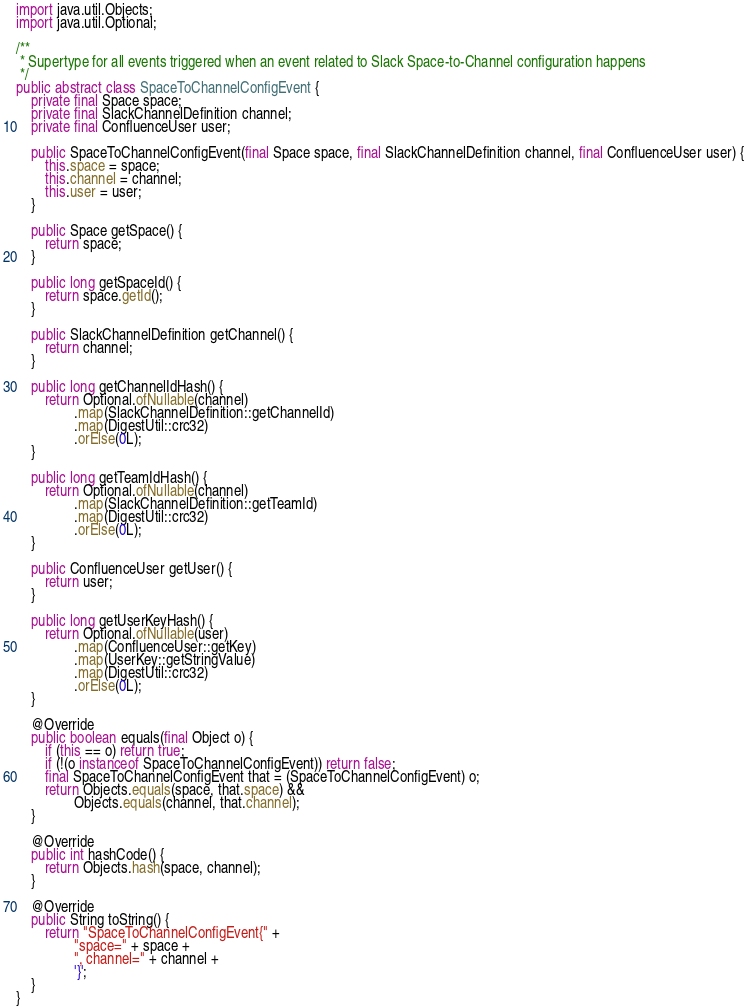Convert code to text. <code><loc_0><loc_0><loc_500><loc_500><_Java_>
import java.util.Objects;
import java.util.Optional;

/**
 * Supertype for all events triggered when an event related to Slack Space-to-Channel configuration happens
 */
public abstract class SpaceToChannelConfigEvent {
    private final Space space;
    private final SlackChannelDefinition channel;
    private final ConfluenceUser user;

    public SpaceToChannelConfigEvent(final Space space, final SlackChannelDefinition channel, final ConfluenceUser user) {
        this.space = space;
        this.channel = channel;
        this.user = user;
    }

    public Space getSpace() {
        return space;
    }

    public long getSpaceId() {
        return space.getId();
    }

    public SlackChannelDefinition getChannel() {
        return channel;
    }

    public long getChannelIdHash() {
        return Optional.ofNullable(channel)
                .map(SlackChannelDefinition::getChannelId)
                .map(DigestUtil::crc32)
                .orElse(0L);
    }

    public long getTeamIdHash() {
        return Optional.ofNullable(channel)
                .map(SlackChannelDefinition::getTeamId)
                .map(DigestUtil::crc32)
                .orElse(0L);
    }

    public ConfluenceUser getUser() {
        return user;
    }

    public long getUserKeyHash() {
        return Optional.ofNullable(user)
                .map(ConfluenceUser::getKey)
                .map(UserKey::getStringValue)
                .map(DigestUtil::crc32)
                .orElse(0L);
    }

    @Override
    public boolean equals(final Object o) {
        if (this == o) return true;
        if (!(o instanceof SpaceToChannelConfigEvent)) return false;
        final SpaceToChannelConfigEvent that = (SpaceToChannelConfigEvent) o;
        return Objects.equals(space, that.space) &&
                Objects.equals(channel, that.channel);
    }

    @Override
    public int hashCode() {
        return Objects.hash(space, channel);
    }

    @Override
    public String toString() {
        return "SpaceToChannelConfigEvent{" +
                "space=" + space +
                ", channel=" + channel +
                '}';
    }
}
</code> 